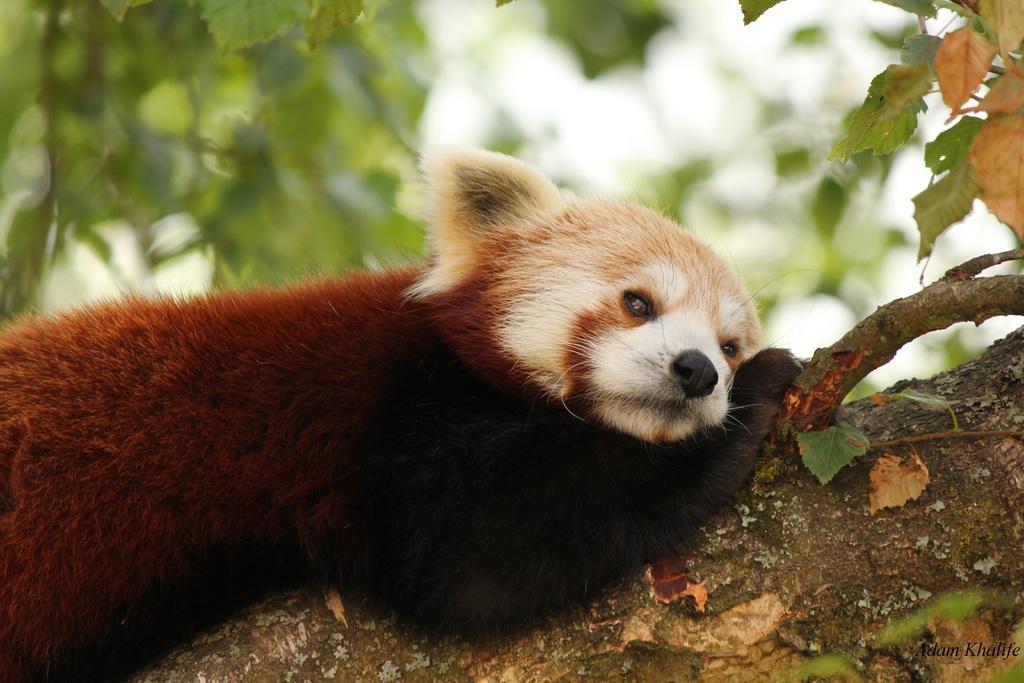In one or two sentences, can you explain what this image depicts? In this image there is a red panda lying on the branch of a tree. There is some text at the bottom of the image. 